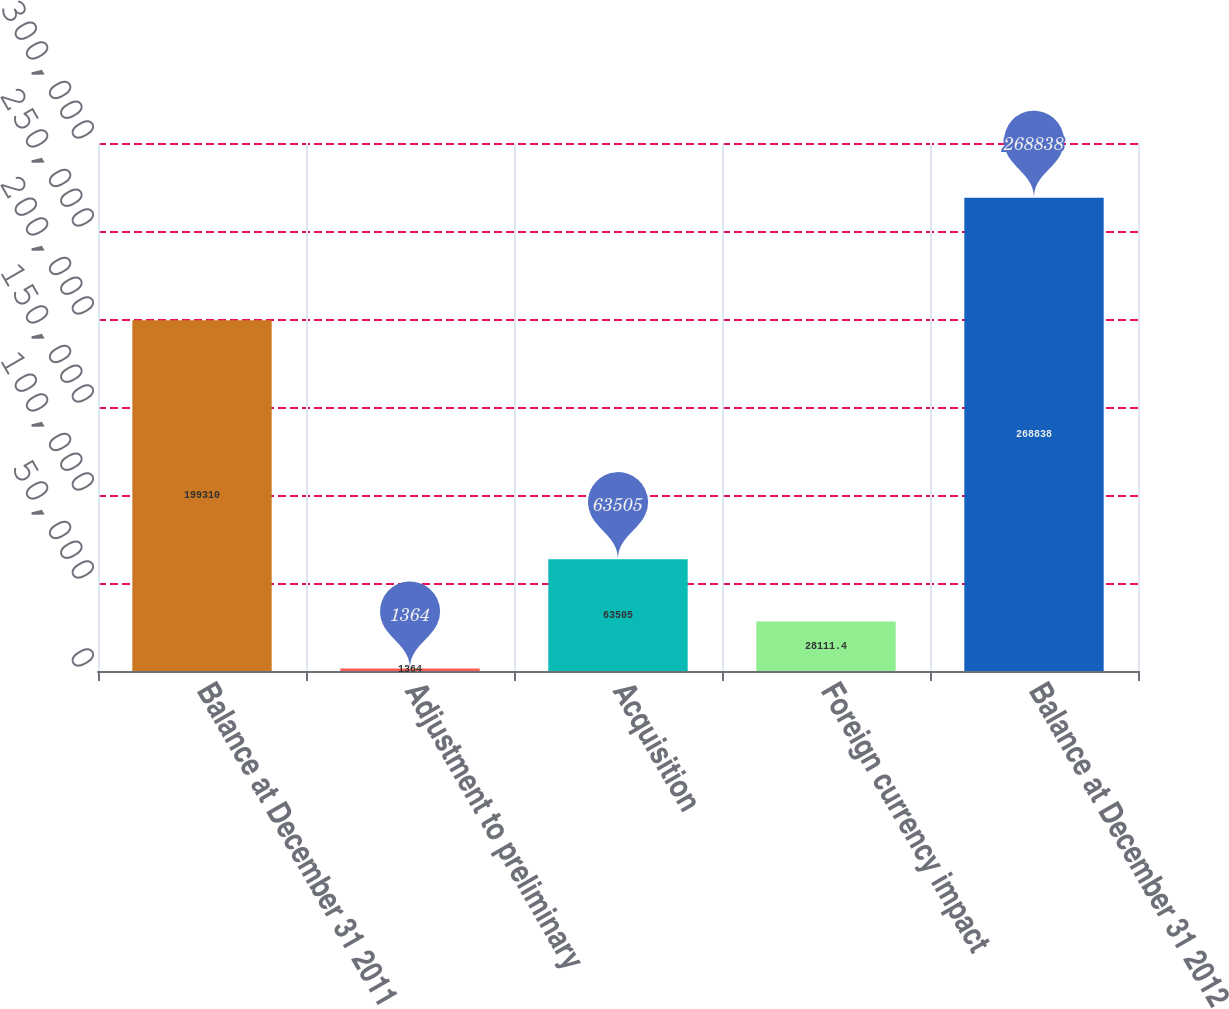Convert chart to OTSL. <chart><loc_0><loc_0><loc_500><loc_500><bar_chart><fcel>Balance at December 31 2011<fcel>Adjustment to preliminary<fcel>Acquisition<fcel>Foreign currency impact<fcel>Balance at December 31 2012<nl><fcel>199310<fcel>1364<fcel>63505<fcel>28111.4<fcel>268838<nl></chart> 